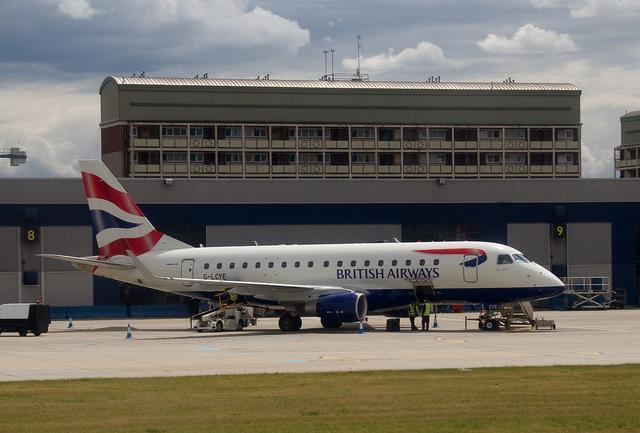How many people in neon vests?
Give a very brief answer. 2. How many planes are on the ground?
Give a very brief answer. 1. 